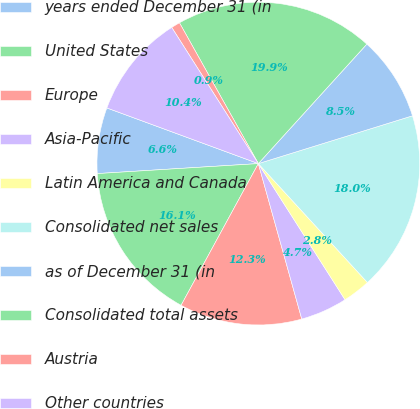<chart> <loc_0><loc_0><loc_500><loc_500><pie_chart><fcel>years ended December 31 (in<fcel>United States<fcel>Europe<fcel>Asia-Pacific<fcel>Latin America and Canada<fcel>Consolidated net sales<fcel>as of December 31 (in<fcel>Consolidated total assets<fcel>Austria<fcel>Other countries<nl><fcel>6.59%<fcel>16.07%<fcel>12.28%<fcel>4.69%<fcel>2.79%<fcel>17.97%<fcel>8.48%<fcel>19.86%<fcel>0.89%<fcel>10.38%<nl></chart> 